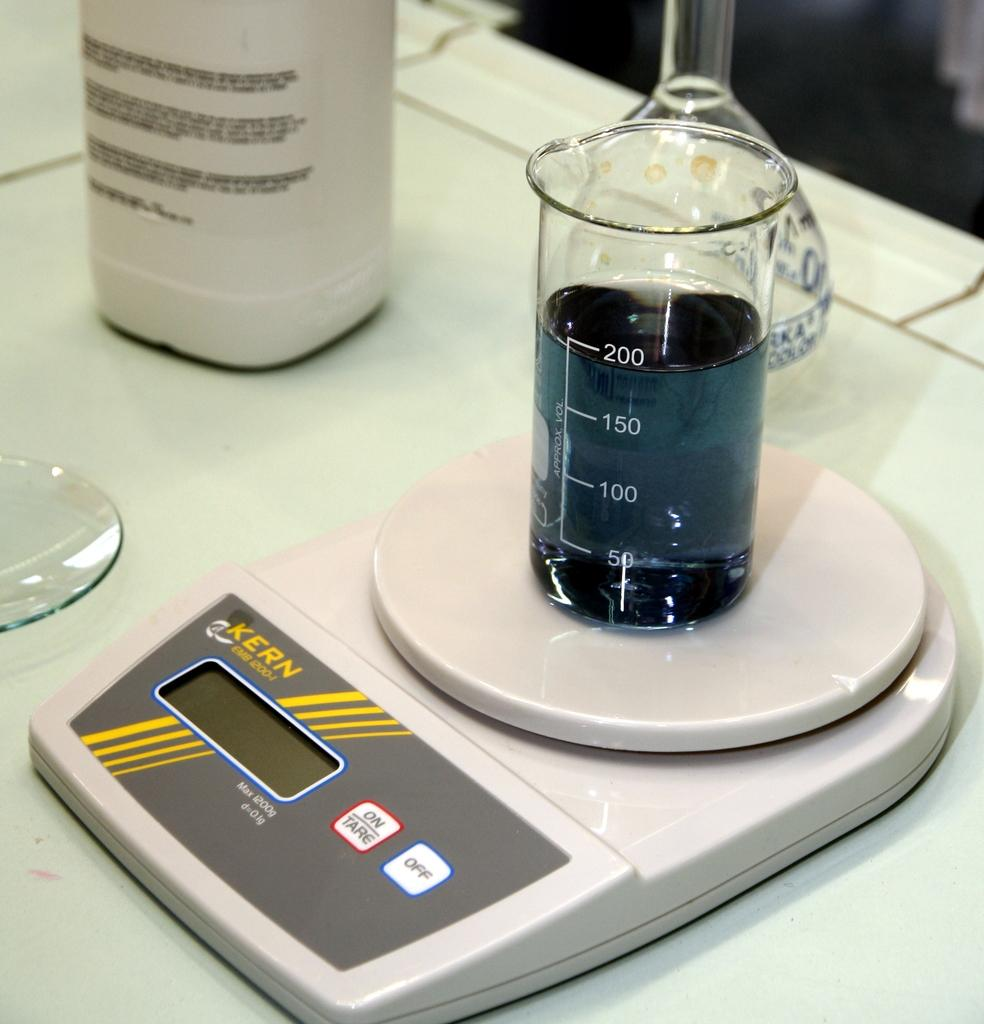<image>
Write a terse but informative summary of the picture. The liquid in the containeron the scales is around 200 ml. 